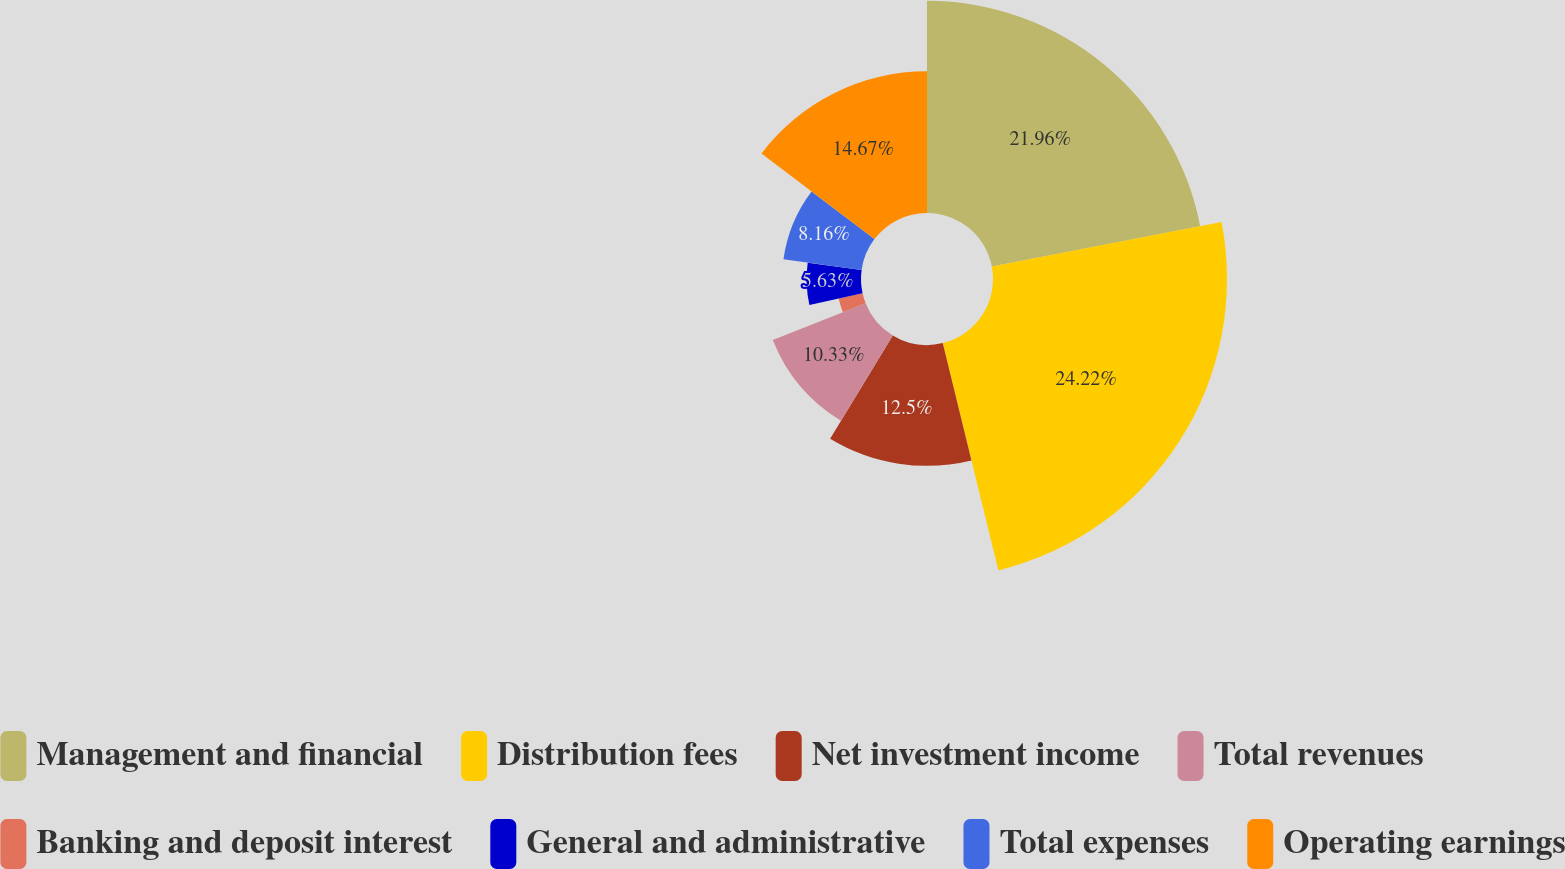Convert chart. <chart><loc_0><loc_0><loc_500><loc_500><pie_chart><fcel>Management and financial<fcel>Distribution fees<fcel>Net investment income<fcel>Total revenues<fcel>Banking and deposit interest<fcel>General and administrative<fcel>Total expenses<fcel>Operating earnings<nl><fcel>21.96%<fcel>24.21%<fcel>12.5%<fcel>10.33%<fcel>2.53%<fcel>5.63%<fcel>8.16%<fcel>14.67%<nl></chart> 